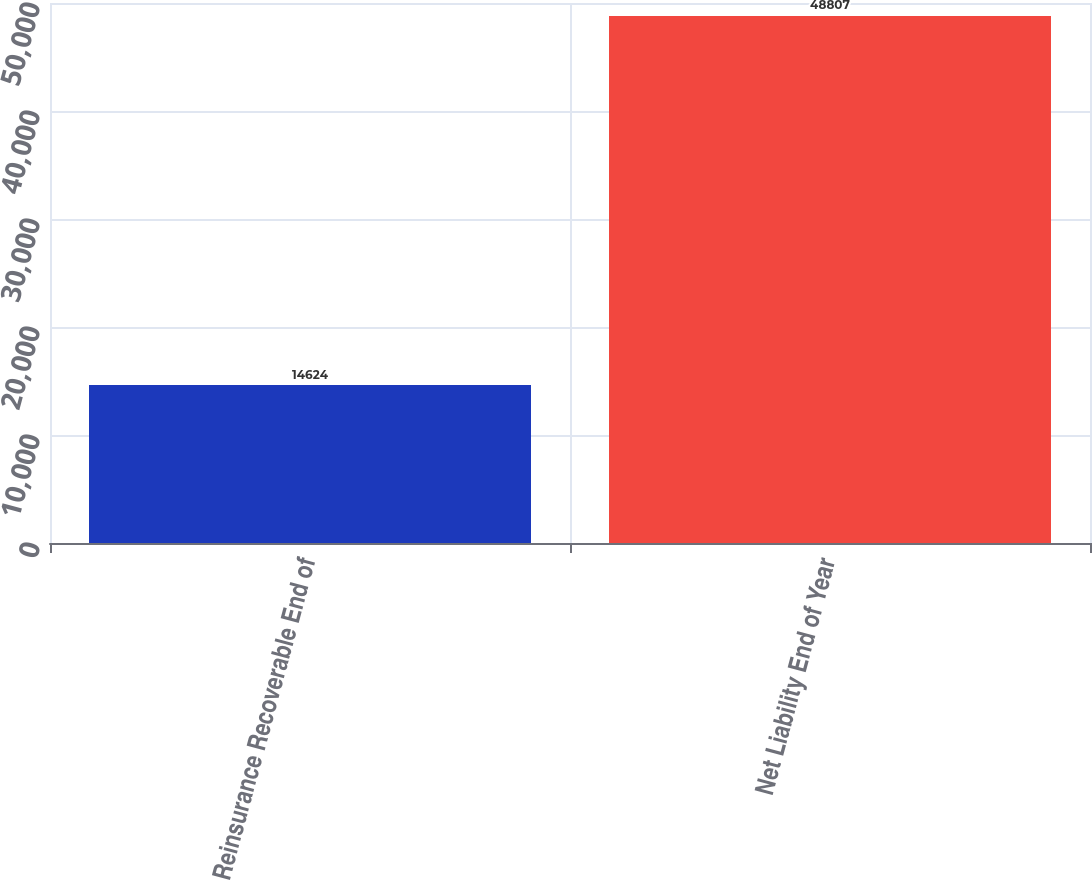Convert chart to OTSL. <chart><loc_0><loc_0><loc_500><loc_500><bar_chart><fcel>Reinsurance Recoverable End of<fcel>Net Liability End of Year<nl><fcel>14624<fcel>48807<nl></chart> 